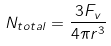Convert formula to latex. <formula><loc_0><loc_0><loc_500><loc_500>N _ { t o t a l } = \frac { 3 F _ { v } } { 4 \pi r ^ { 3 } }</formula> 